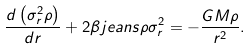<formula> <loc_0><loc_0><loc_500><loc_500>\frac { d \left ( \sigma ^ { 2 } _ { r } \rho \right ) } { d r } + 2 \beta j e a n s \rho \sigma ^ { 2 } _ { r } = - \frac { G M \rho } { r ^ { 2 } } .</formula> 